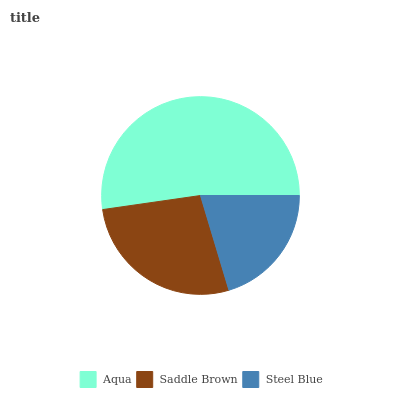Is Steel Blue the minimum?
Answer yes or no. Yes. Is Aqua the maximum?
Answer yes or no. Yes. Is Saddle Brown the minimum?
Answer yes or no. No. Is Saddle Brown the maximum?
Answer yes or no. No. Is Aqua greater than Saddle Brown?
Answer yes or no. Yes. Is Saddle Brown less than Aqua?
Answer yes or no. Yes. Is Saddle Brown greater than Aqua?
Answer yes or no. No. Is Aqua less than Saddle Brown?
Answer yes or no. No. Is Saddle Brown the high median?
Answer yes or no. Yes. Is Saddle Brown the low median?
Answer yes or no. Yes. Is Aqua the high median?
Answer yes or no. No. Is Steel Blue the low median?
Answer yes or no. No. 